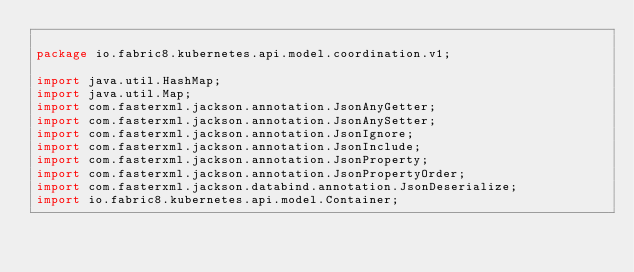<code> <loc_0><loc_0><loc_500><loc_500><_Java_>
package io.fabric8.kubernetes.api.model.coordination.v1;

import java.util.HashMap;
import java.util.Map;
import com.fasterxml.jackson.annotation.JsonAnyGetter;
import com.fasterxml.jackson.annotation.JsonAnySetter;
import com.fasterxml.jackson.annotation.JsonIgnore;
import com.fasterxml.jackson.annotation.JsonInclude;
import com.fasterxml.jackson.annotation.JsonProperty;
import com.fasterxml.jackson.annotation.JsonPropertyOrder;
import com.fasterxml.jackson.databind.annotation.JsonDeserialize;
import io.fabric8.kubernetes.api.model.Container;</code> 